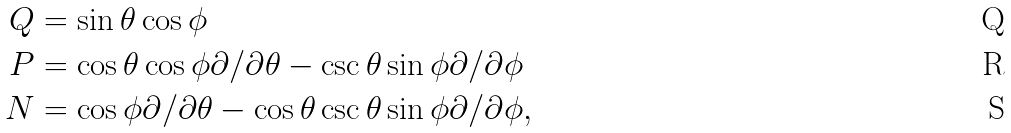<formula> <loc_0><loc_0><loc_500><loc_500>Q & = \sin \theta \cos \phi \\ P & = \cos \theta \cos \phi \partial / \partial \theta - \csc \theta \sin \phi \partial / \partial \phi \\ N & = \cos \phi \partial / \partial \theta - \cos \theta \csc \theta \sin \phi \partial / \partial \phi ,</formula> 